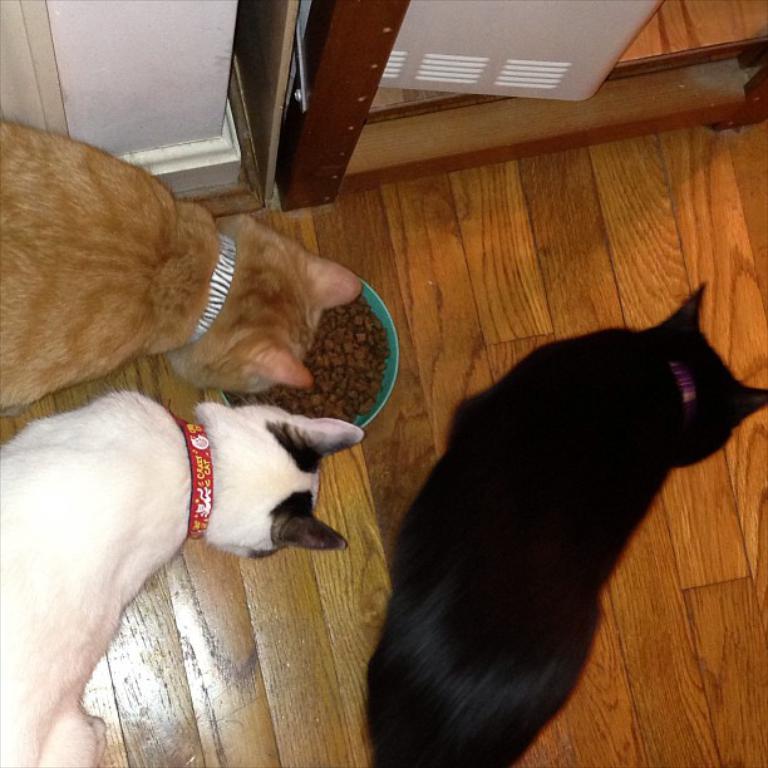Could you give a brief overview of what you see in this image? In this image there are dogs. In the center we can see a bowl containing food. At the bottom there is a floor. In the background there is a door and a wall. 